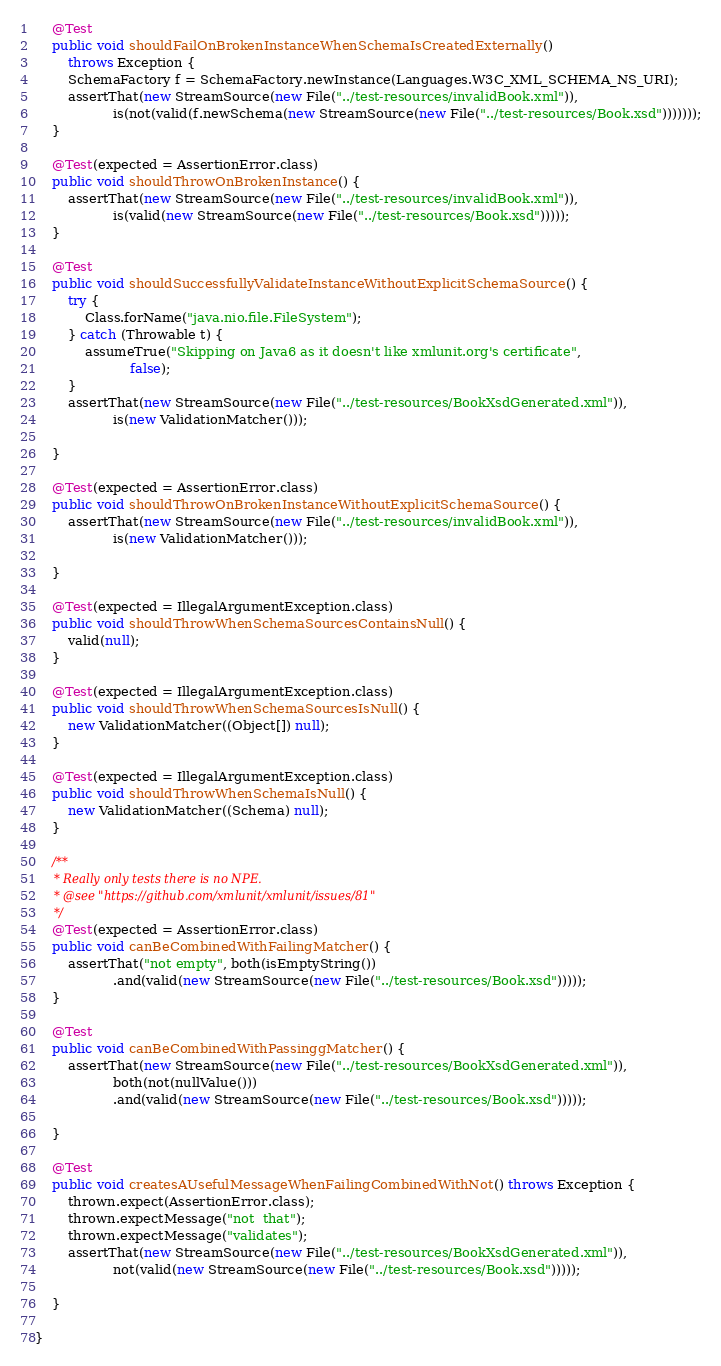<code> <loc_0><loc_0><loc_500><loc_500><_Java_>
    @Test
    public void shouldFailOnBrokenInstanceWhenSchemaIsCreatedExternally()
        throws Exception {
        SchemaFactory f = SchemaFactory.newInstance(Languages.W3C_XML_SCHEMA_NS_URI);
        assertThat(new StreamSource(new File("../test-resources/invalidBook.xml")),
                   is(not(valid(f.newSchema(new StreamSource(new File("../test-resources/Book.xsd")))))));
    }

    @Test(expected = AssertionError.class)
    public void shouldThrowOnBrokenInstance() {
        assertThat(new StreamSource(new File("../test-resources/invalidBook.xml")),
                   is(valid(new StreamSource(new File("../test-resources/Book.xsd")))));
    }

    @Test
    public void shouldSuccessfullyValidateInstanceWithoutExplicitSchemaSource() {
        try {
            Class.forName("java.nio.file.FileSystem");
        } catch (Throwable t) {
            assumeTrue("Skipping on Java6 as it doesn't like xmlunit.org's certificate",
                       false);
        }
        assertThat(new StreamSource(new File("../test-resources/BookXsdGenerated.xml")),
                   is(new ValidationMatcher()));

    }

    @Test(expected = AssertionError.class)
    public void shouldThrowOnBrokenInstanceWithoutExplicitSchemaSource() {
        assertThat(new StreamSource(new File("../test-resources/invalidBook.xml")),
                   is(new ValidationMatcher()));

    }

    @Test(expected = IllegalArgumentException.class)
    public void shouldThrowWhenSchemaSourcesContainsNull() {
        valid(null);
    }

    @Test(expected = IllegalArgumentException.class)
    public void shouldThrowWhenSchemaSourcesIsNull() {
        new ValidationMatcher((Object[]) null);
    }

    @Test(expected = IllegalArgumentException.class)
    public void shouldThrowWhenSchemaIsNull() {
        new ValidationMatcher((Schema) null);
    }

    /**
     * Really only tests there is no NPE.
     * @see "https://github.com/xmlunit/xmlunit/issues/81"
     */
    @Test(expected = AssertionError.class)
    public void canBeCombinedWithFailingMatcher() {
        assertThat("not empty", both(isEmptyString())
                   .and(valid(new StreamSource(new File("../test-resources/Book.xsd")))));
    }

    @Test
    public void canBeCombinedWithPassinggMatcher() {
        assertThat(new StreamSource(new File("../test-resources/BookXsdGenerated.xml")),
                   both(not(nullValue()))
                   .and(valid(new StreamSource(new File("../test-resources/Book.xsd")))));

    }

    @Test
    public void createsAUsefulMessageWhenFailingCombinedWithNot() throws Exception {
        thrown.expect(AssertionError.class);
        thrown.expectMessage("not  that");
        thrown.expectMessage("validates");
        assertThat(new StreamSource(new File("../test-resources/BookXsdGenerated.xml")),
                   not(valid(new StreamSource(new File("../test-resources/Book.xsd")))));

    }

}
</code> 